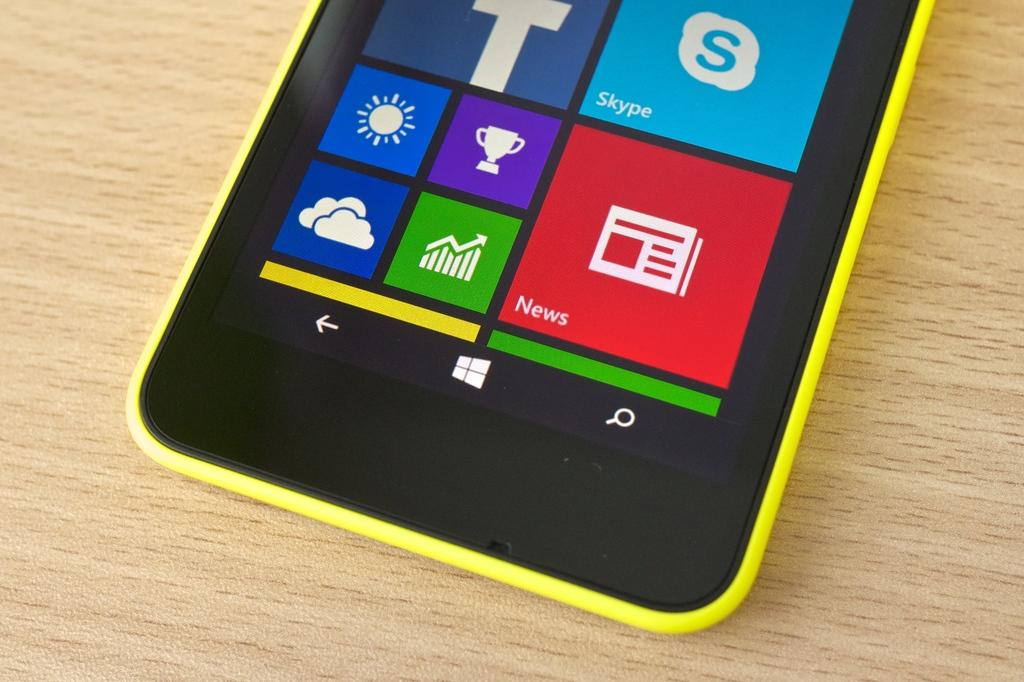<image>
Give a short and clear explanation of the subsequent image. The red square on the phone screen shown is for news. 